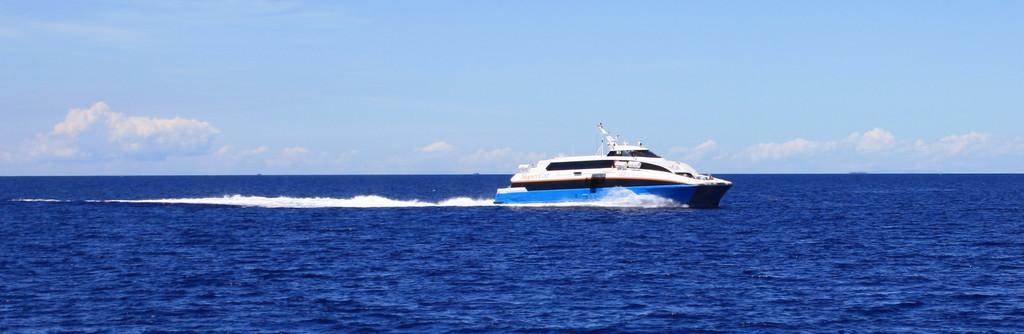What is the main subject of the image? There is a ship in the image. Where is the ship located? The ship is on a river. What can be seen in the background of the image? There is sky visible in the background of the image. How many kittens are sitting on the chair in the image? There are no kittens or chairs present in the image. Is there a notebook visible on the ship in the image? There is no mention of a notebook in the image, only the ship and its location on the river. 